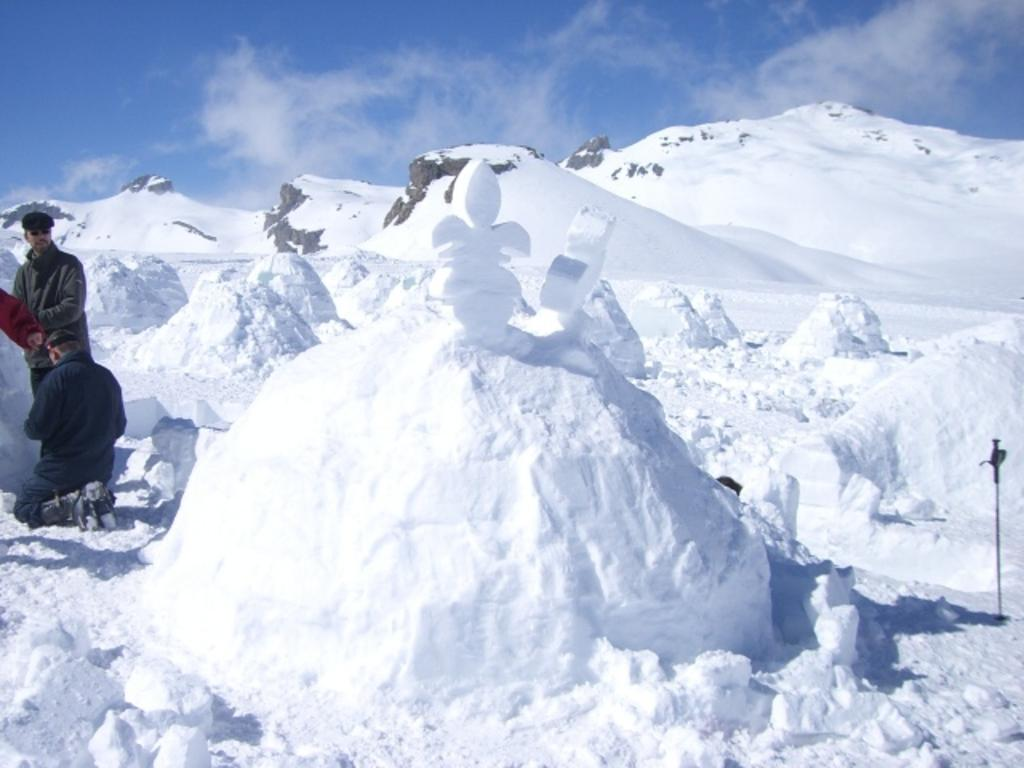What type of terrain is visible in the image? The image contains mountains covered with snow. Can you describe the snow in the image? There is snow at the bottom of the image. Where are the three persons located in the image? The three persons wearing jackets are on the left side of the image. What is visible at the top of the image? The sky is visible at the top of the image. What type of cracker is being used to twist the monkey's tail in the image? There is no cracker or monkey present in the image; it features snow-covered mountains and three persons wearing jackets. 